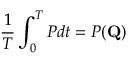Convert formula to latex. <formula><loc_0><loc_0><loc_500><loc_500>\frac { 1 } { T } \int _ { 0 } ^ { T } P d t = P ( Q )</formula> 